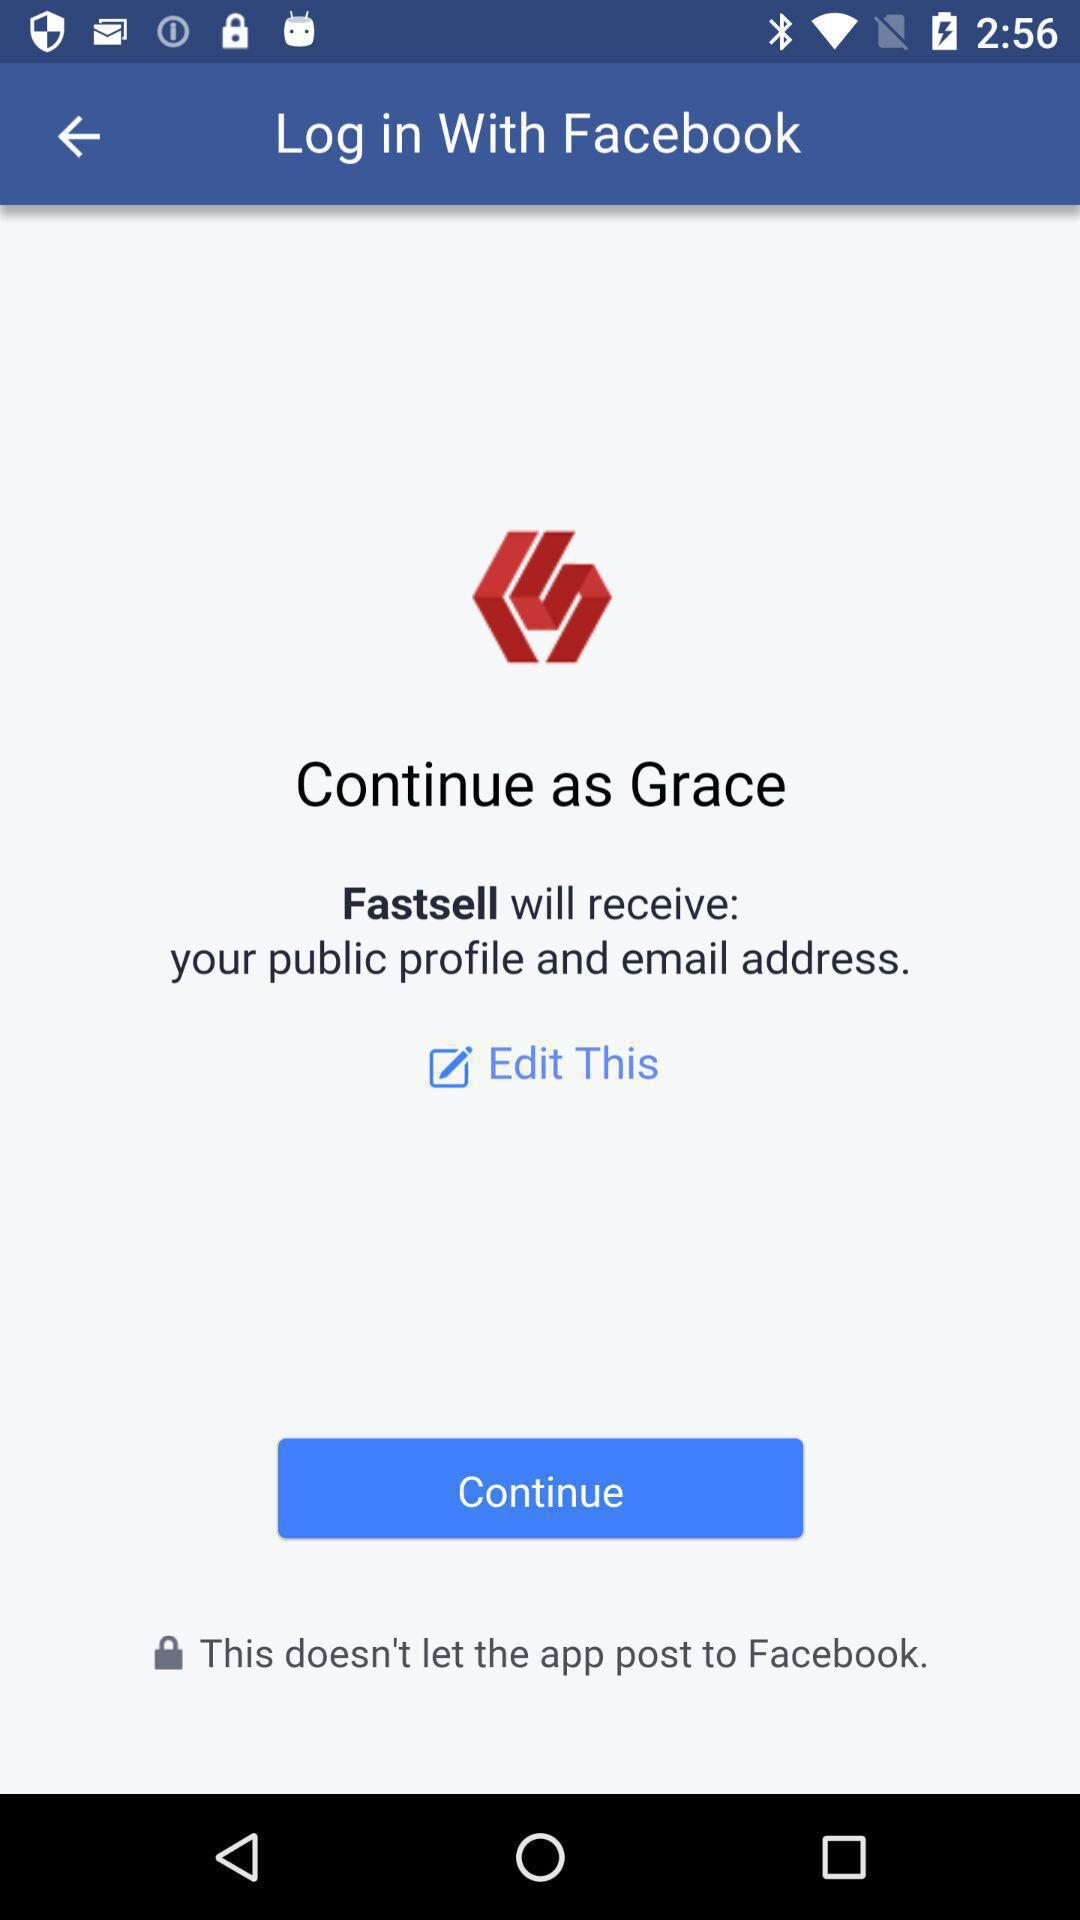What is the login name? The login name is Grace. 